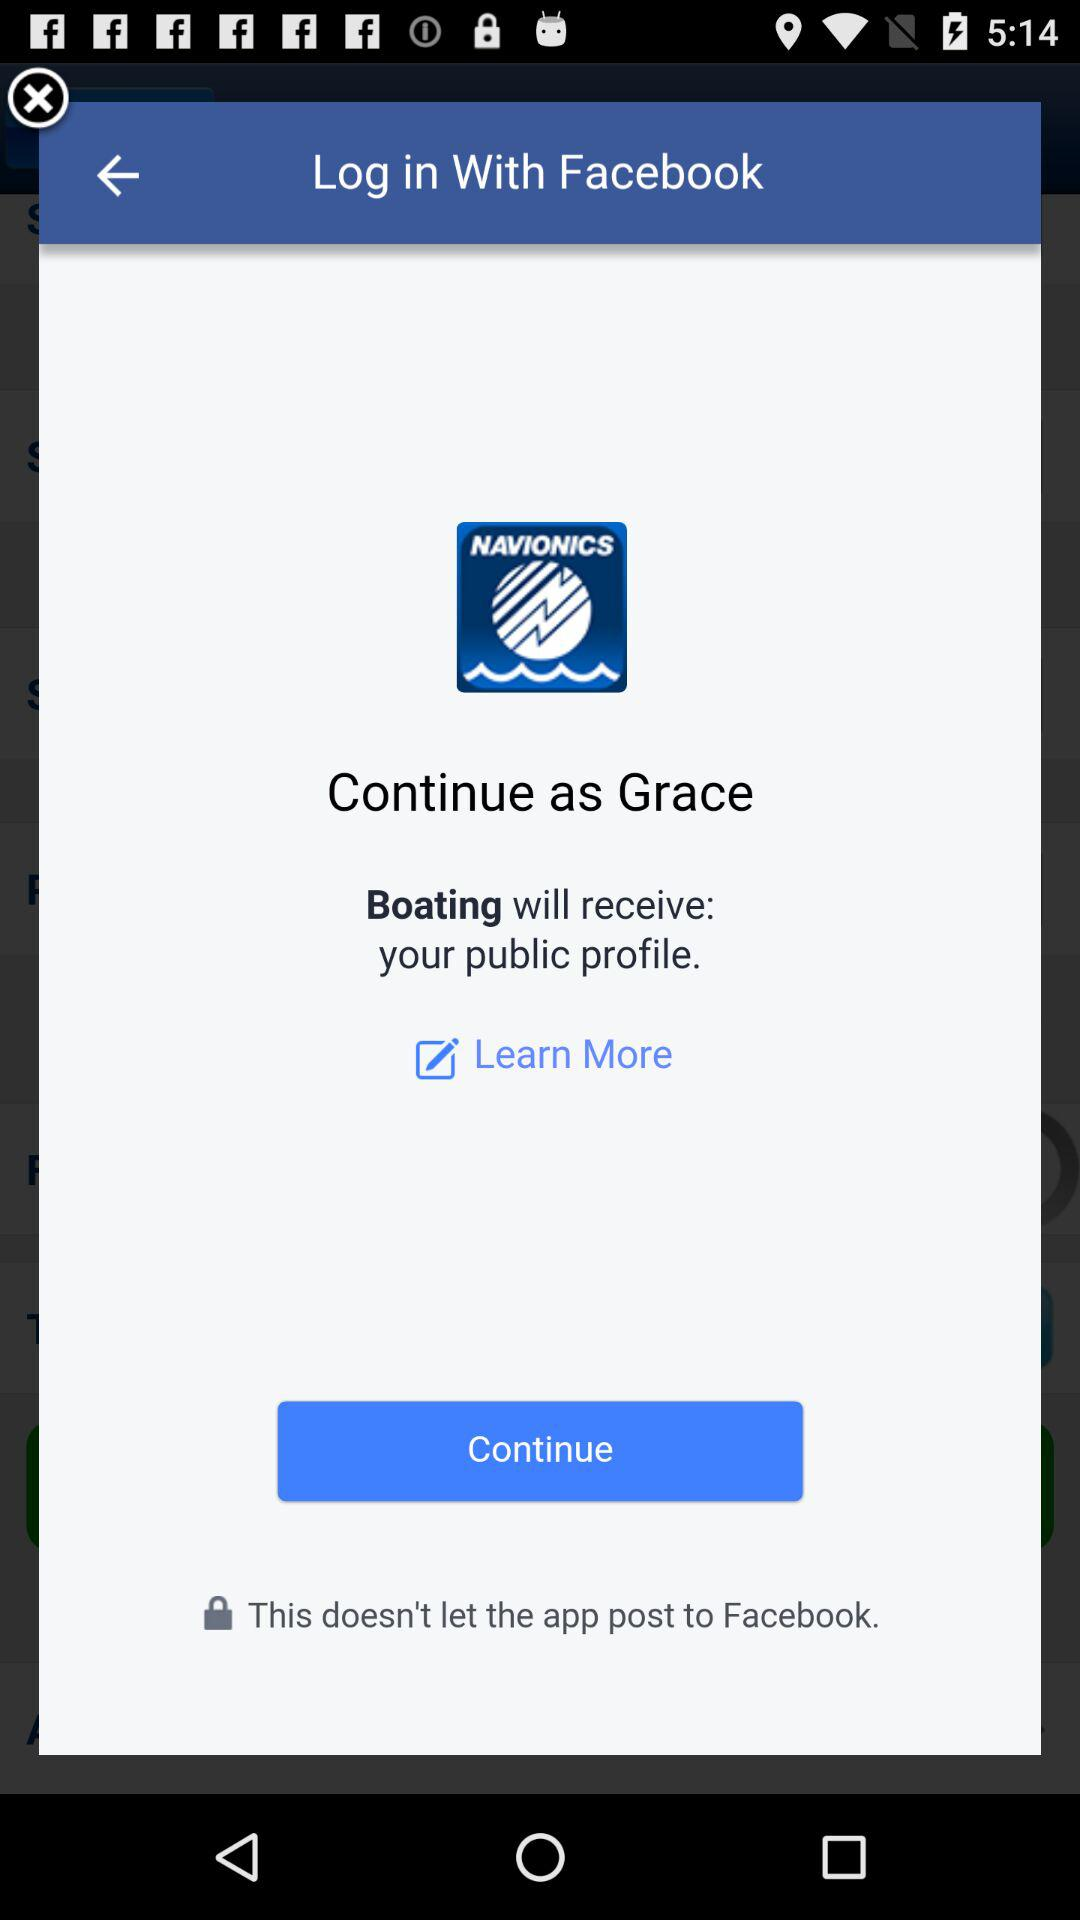What is the name of the user? The name of the user is Grace. 